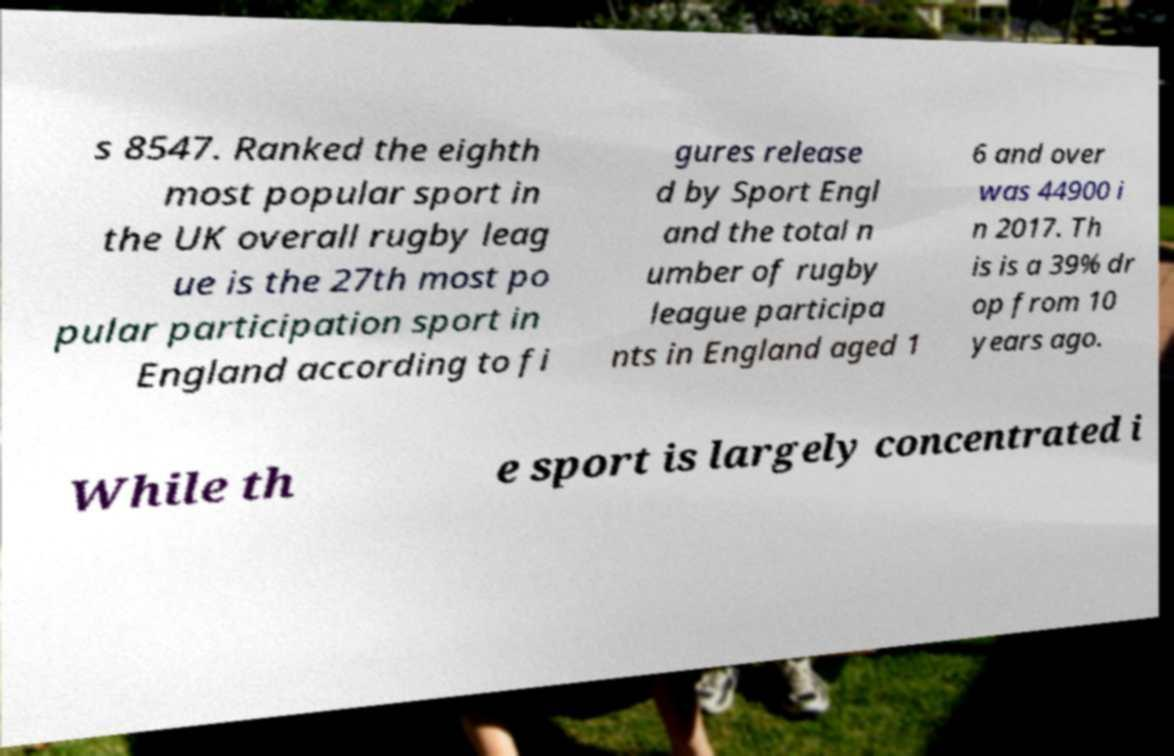Could you assist in decoding the text presented in this image and type it out clearly? s 8547. Ranked the eighth most popular sport in the UK overall rugby leag ue is the 27th most po pular participation sport in England according to fi gures release d by Sport Engl and the total n umber of rugby league participa nts in England aged 1 6 and over was 44900 i n 2017. Th is is a 39% dr op from 10 years ago. While th e sport is largely concentrated i 